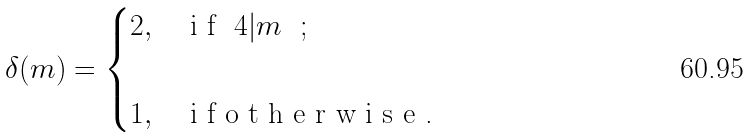Convert formula to latex. <formula><loc_0><loc_0><loc_500><loc_500>\delta ( m ) = \begin{cases} 2 , & $ i f { $ 4 | m $ } $ ; \\ \\ 1 , & $ i f o t h e r w i s e . $ \end{cases}</formula> 